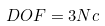<formula> <loc_0><loc_0><loc_500><loc_500>D O F = 3 N c</formula> 